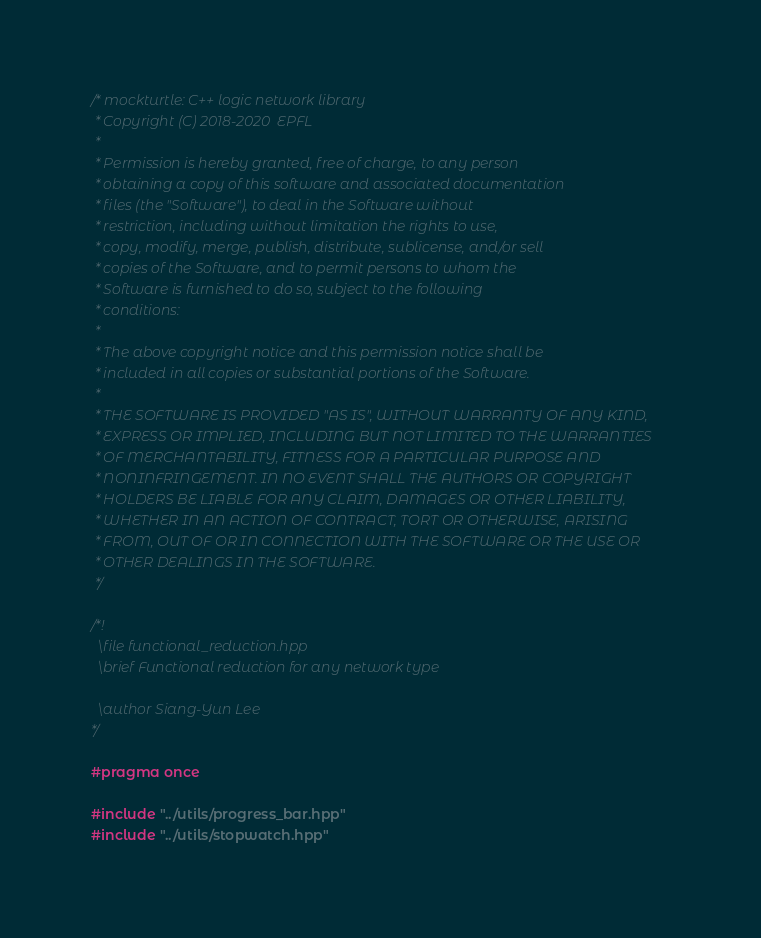<code> <loc_0><loc_0><loc_500><loc_500><_C++_>/* mockturtle: C++ logic network library
 * Copyright (C) 2018-2020  EPFL
 *
 * Permission is hereby granted, free of charge, to any person
 * obtaining a copy of this software and associated documentation
 * files (the "Software"), to deal in the Software without
 * restriction, including without limitation the rights to use,
 * copy, modify, merge, publish, distribute, sublicense, and/or sell
 * copies of the Software, and to permit persons to whom the
 * Software is furnished to do so, subject to the following
 * conditions:
 *
 * The above copyright notice and this permission notice shall be
 * included in all copies or substantial portions of the Software.
 *
 * THE SOFTWARE IS PROVIDED "AS IS", WITHOUT WARRANTY OF ANY KIND,
 * EXPRESS OR IMPLIED, INCLUDING BUT NOT LIMITED TO THE WARRANTIES
 * OF MERCHANTABILITY, FITNESS FOR A PARTICULAR PURPOSE AND
 * NONINFRINGEMENT. IN NO EVENT SHALL THE AUTHORS OR COPYRIGHT
 * HOLDERS BE LIABLE FOR ANY CLAIM, DAMAGES OR OTHER LIABILITY,
 * WHETHER IN AN ACTION OF CONTRACT, TORT OR OTHERWISE, ARISING
 * FROM, OUT OF OR IN CONNECTION WITH THE SOFTWARE OR THE USE OR
 * OTHER DEALINGS IN THE SOFTWARE.
 */

/*!
  \file functional_reduction.hpp
  \brief Functional reduction for any network type

  \author Siang-Yun Lee
*/

#pragma once

#include "../utils/progress_bar.hpp"
#include "../utils/stopwatch.hpp"</code> 